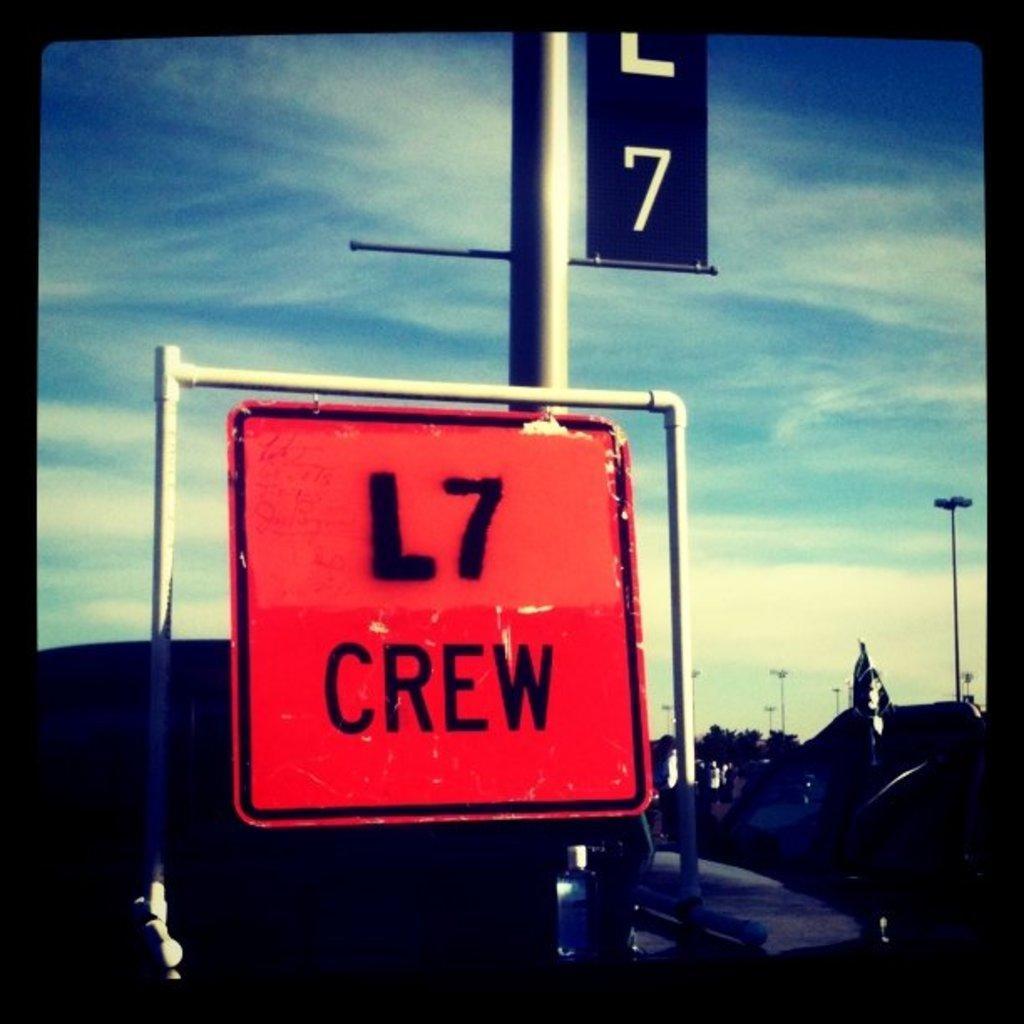Describe this image in one or two sentences. This picture is an edited picture. In the foreground there are boards on the pole, there is a text on the board. At the back there are buildings, trees and poles. At the top there is sky and there are clouds. 